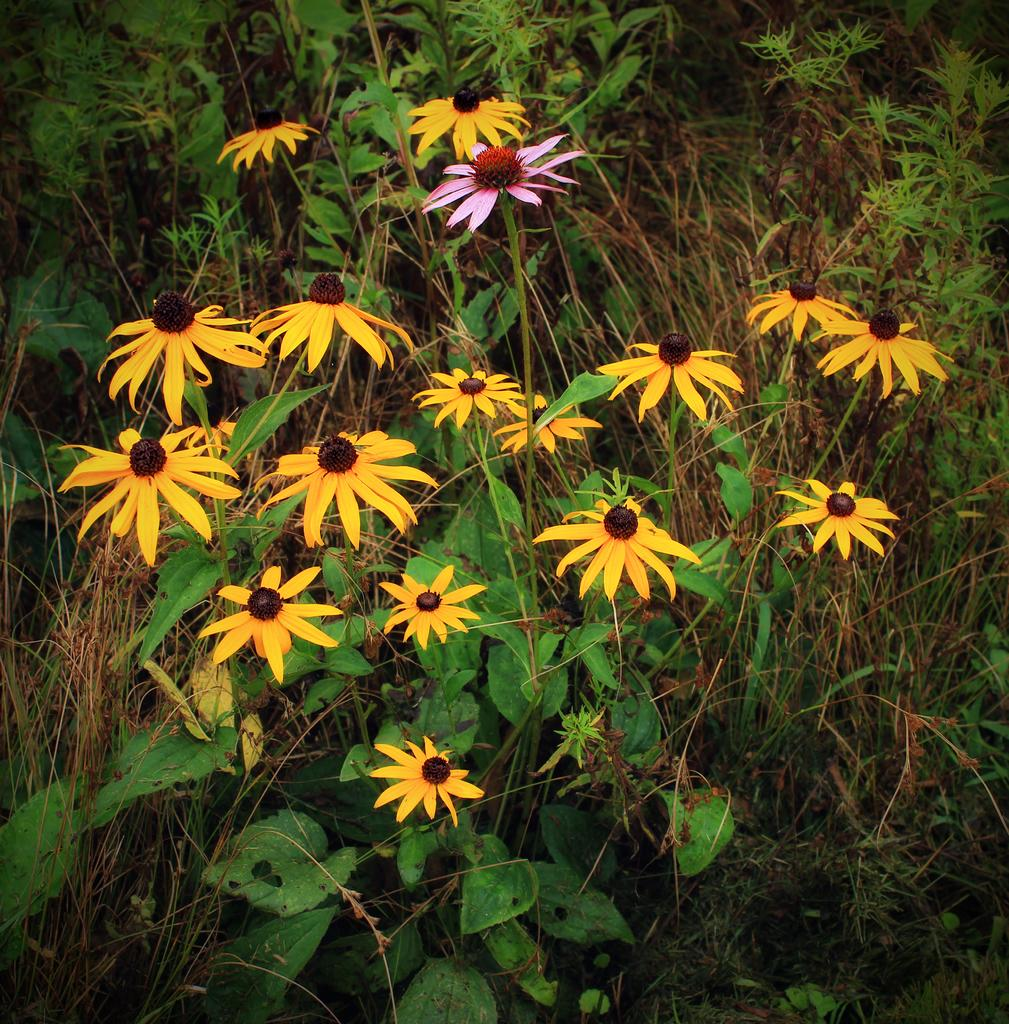What is the main subject of the image? The main subject of the image is flower plants. Where are the flower plants located in the image? The flower plants are in the center of the image. What type of crime is being committed in the image? There is no crime present in the image; it features flower plants in the center. How hot is the temperature in the image? The temperature is not mentioned or depicted in the image, as it only shows flower plants in the center. 